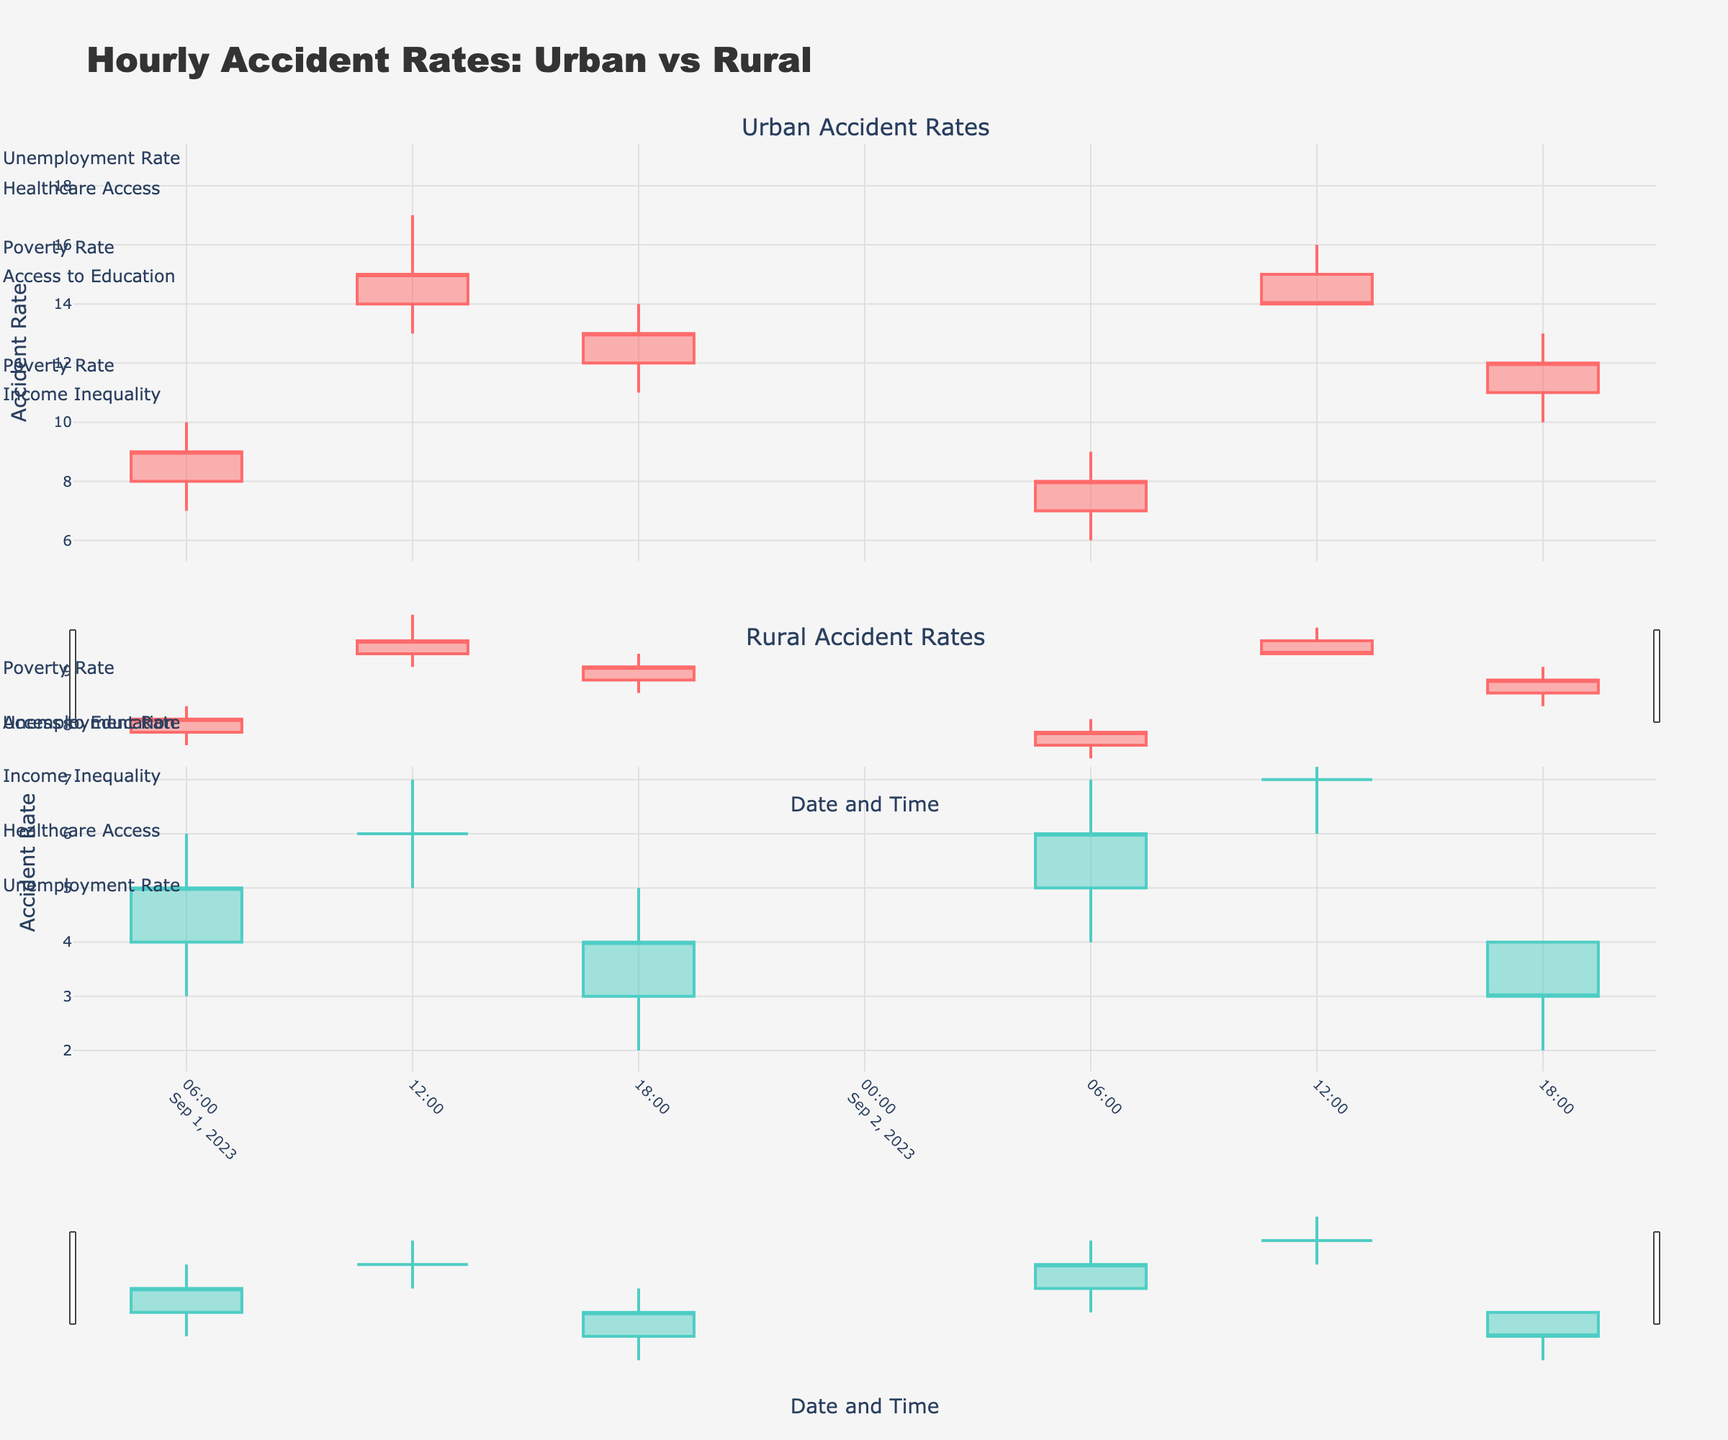what is the overall title of the figure? The title of the figure is displayed at the top and encapsulates the main idea being visualized. It provides a concise summary of what the figure represents. By looking at the top of the figure, you can see that the title is "Hourly Accident Rates: Urban vs Rural".
Answer: "Hourly Accident Rates: Urban vs Rural" what do the colors red and teal represent in the figure? In the figure, different colors are used to differentiate between Urban and Rural accident rates. The red color is used to represent Urban accident rates while the teal color is used to denote Rural accident rates. By examining the candlestick traces, one can identify the specific color associated with each location.
Answer: Urban is red, Rural is teal what are the socio-economic factors shown for rural accident rates on 2023-09-01? The socio-economic factors are annotated on the figure using small tags next to the highest points of the candlesticks. By looking at each candlestick for 2023-09-01's rural accident rates, you can see the annotations which list these factors: 06:00 - Income Inequality, 12:00 - Access to Education, 18:00 - Healthcare Access.
Answer: Income Inequality, Access to Education, Healthcare Access how do the Urban accident rates compare to the Rural rates at 12:00 on 2023-09-01? To compare the accident rates at a specific time, look at the candlesticks for Urban and Rural at 12:00 on 2023-09-01. The Urban rate opens at 14, peaks at 17, has a low of 13, and closes at 15. The Rural rate opens at 6, peaks at 7, has a low of 5, and closes at 6. This shows Urban rates are significantly higher.
Answer: Urban rates are significantly higher what is the median close value for Urban accident rates on 2023-09-02? The close values for Urban accident rates on 2023-09-02 are listed as: 06:00 - 8, 12:00 - 14, 18:00 - 12. To find the median, sort the values: 8, 12, 14. The median is the middle value, which is 12.
Answer: 12 which location has the higher high value at 18:00 on 2023-09-02? By looking at the candlesticks for 18:00 on 2023-09-02 for both Urban and Rural locations, the high values can be identified. Urban's high is 13, and Rural's high is 4. Therefore, Urban has the higher high value.
Answer: Urban what socio-economic factor correlates with the highest Urban accident rate on 2023-09-01? Identify the highest Urban accident rate by looking at the high values on 2023-09-01. The highest is at 12:00 with a peak of 17. The associated socio-economic factor annotated here is "Unemployment Rate".
Answer: Unemployment Rate what is the average open value for Rural accident rates on 2023-09-02? The open values for Rural accident rates on 2023-09-02 are: 06:00 - 5, 12:00 - 7, 18:00 - 4. To find the average, sum the values (5 + 7 + 4 = 16) and divide by the number of values (3), which gives an average of 16/3 ≈ 5.33.
Answer: 5.33 which of the two locations has a more volatile accident rate on the morning of 2023-09-02? Volatility can be assessed by the range (high - low) of the candlesticks. For the morning of 2023-09-02, compare the ranges for Urban (9 - 6 = 3) and Rural (7 - 4 = 3). Both locations have the same range, indicating equal volatility.
Answer: Equal volatility 